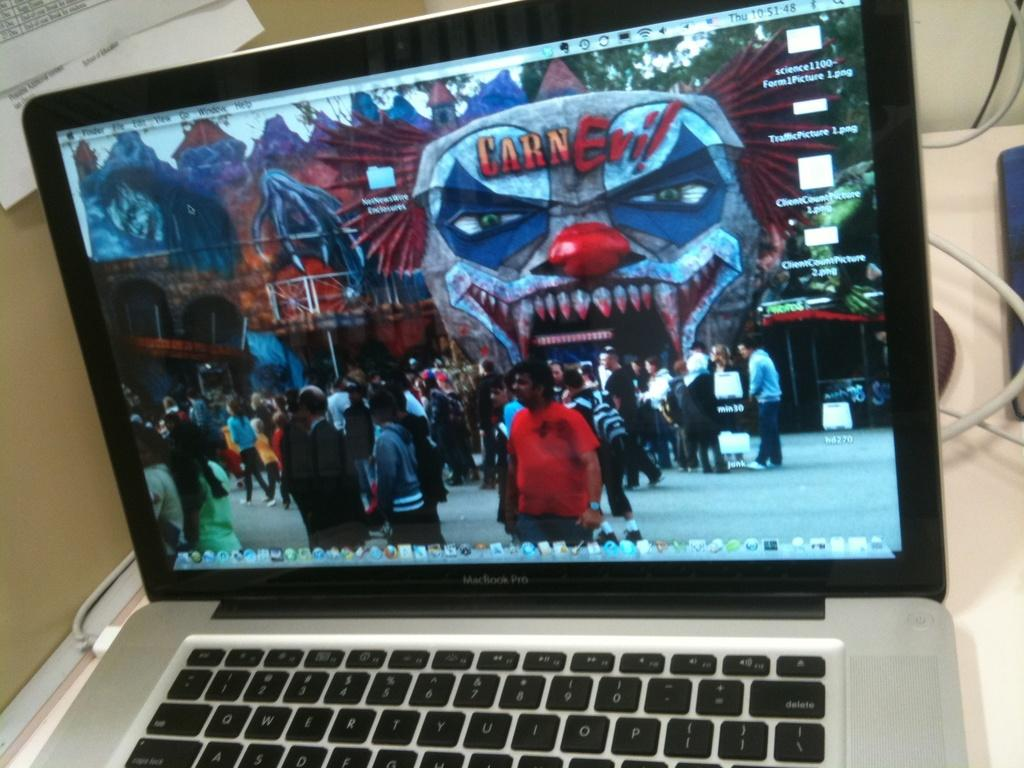<image>
Give a short and clear explanation of the subsequent image. A laptop with a picture of carnevil on the screen. 